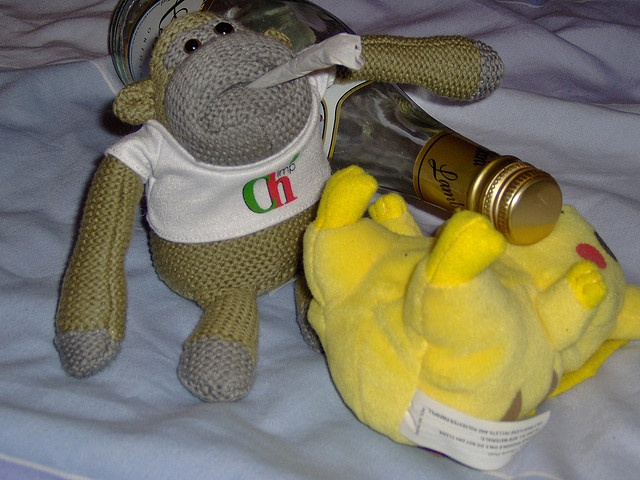Describe the objects in this image and their specific colors. I can see bed in gray tones, teddy bear in gray, olive, gold, and khaki tones, and bottle in gray, black, olive, and maroon tones in this image. 